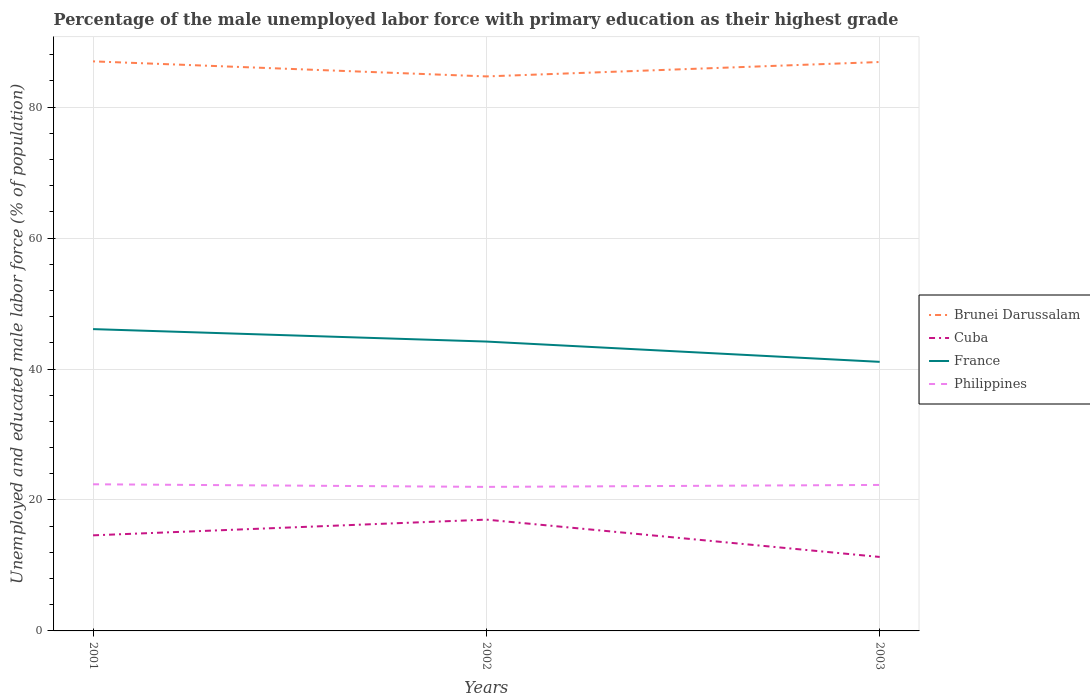How many different coloured lines are there?
Give a very brief answer. 4. Does the line corresponding to Philippines intersect with the line corresponding to Cuba?
Make the answer very short. No. Across all years, what is the maximum percentage of the unemployed male labor force with primary education in France?
Provide a succinct answer. 41.1. What is the total percentage of the unemployed male labor force with primary education in Brunei Darussalam in the graph?
Offer a very short reply. 2.3. What is the difference between the highest and the second highest percentage of the unemployed male labor force with primary education in Philippines?
Ensure brevity in your answer.  0.4. What is the difference between the highest and the lowest percentage of the unemployed male labor force with primary education in France?
Provide a succinct answer. 2. How many years are there in the graph?
Make the answer very short. 3. Are the values on the major ticks of Y-axis written in scientific E-notation?
Offer a very short reply. No. Does the graph contain any zero values?
Your answer should be compact. No. Where does the legend appear in the graph?
Provide a succinct answer. Center right. How are the legend labels stacked?
Make the answer very short. Vertical. What is the title of the graph?
Your answer should be compact. Percentage of the male unemployed labor force with primary education as their highest grade. What is the label or title of the Y-axis?
Provide a short and direct response. Unemployed and educated male labor force (% of population). What is the Unemployed and educated male labor force (% of population) of Cuba in 2001?
Provide a short and direct response. 14.6. What is the Unemployed and educated male labor force (% of population) of France in 2001?
Offer a terse response. 46.1. What is the Unemployed and educated male labor force (% of population) of Philippines in 2001?
Offer a terse response. 22.4. What is the Unemployed and educated male labor force (% of population) of Brunei Darussalam in 2002?
Provide a succinct answer. 84.7. What is the Unemployed and educated male labor force (% of population) of France in 2002?
Make the answer very short. 44.2. What is the Unemployed and educated male labor force (% of population) of Brunei Darussalam in 2003?
Provide a short and direct response. 86.9. What is the Unemployed and educated male labor force (% of population) of Cuba in 2003?
Your answer should be very brief. 11.3. What is the Unemployed and educated male labor force (% of population) in France in 2003?
Make the answer very short. 41.1. What is the Unemployed and educated male labor force (% of population) of Philippines in 2003?
Provide a succinct answer. 22.3. Across all years, what is the maximum Unemployed and educated male labor force (% of population) in Cuba?
Make the answer very short. 17. Across all years, what is the maximum Unemployed and educated male labor force (% of population) in France?
Offer a very short reply. 46.1. Across all years, what is the maximum Unemployed and educated male labor force (% of population) of Philippines?
Provide a short and direct response. 22.4. Across all years, what is the minimum Unemployed and educated male labor force (% of population) in Brunei Darussalam?
Your answer should be very brief. 84.7. Across all years, what is the minimum Unemployed and educated male labor force (% of population) of Cuba?
Offer a very short reply. 11.3. Across all years, what is the minimum Unemployed and educated male labor force (% of population) in France?
Offer a terse response. 41.1. What is the total Unemployed and educated male labor force (% of population) in Brunei Darussalam in the graph?
Your response must be concise. 258.6. What is the total Unemployed and educated male labor force (% of population) of Cuba in the graph?
Your answer should be compact. 42.9. What is the total Unemployed and educated male labor force (% of population) of France in the graph?
Your response must be concise. 131.4. What is the total Unemployed and educated male labor force (% of population) of Philippines in the graph?
Keep it short and to the point. 66.7. What is the difference between the Unemployed and educated male labor force (% of population) in Philippines in 2001 and that in 2002?
Ensure brevity in your answer.  0.4. What is the difference between the Unemployed and educated male labor force (% of population) of Philippines in 2002 and that in 2003?
Offer a very short reply. -0.3. What is the difference between the Unemployed and educated male labor force (% of population) of Brunei Darussalam in 2001 and the Unemployed and educated male labor force (% of population) of Cuba in 2002?
Keep it short and to the point. 70. What is the difference between the Unemployed and educated male labor force (% of population) in Brunei Darussalam in 2001 and the Unemployed and educated male labor force (% of population) in France in 2002?
Make the answer very short. 42.8. What is the difference between the Unemployed and educated male labor force (% of population) in Cuba in 2001 and the Unemployed and educated male labor force (% of population) in France in 2002?
Offer a terse response. -29.6. What is the difference between the Unemployed and educated male labor force (% of population) of France in 2001 and the Unemployed and educated male labor force (% of population) of Philippines in 2002?
Offer a very short reply. 24.1. What is the difference between the Unemployed and educated male labor force (% of population) of Brunei Darussalam in 2001 and the Unemployed and educated male labor force (% of population) of Cuba in 2003?
Keep it short and to the point. 75.7. What is the difference between the Unemployed and educated male labor force (% of population) of Brunei Darussalam in 2001 and the Unemployed and educated male labor force (% of population) of France in 2003?
Provide a short and direct response. 45.9. What is the difference between the Unemployed and educated male labor force (% of population) of Brunei Darussalam in 2001 and the Unemployed and educated male labor force (% of population) of Philippines in 2003?
Give a very brief answer. 64.7. What is the difference between the Unemployed and educated male labor force (% of population) in Cuba in 2001 and the Unemployed and educated male labor force (% of population) in France in 2003?
Your response must be concise. -26.5. What is the difference between the Unemployed and educated male labor force (% of population) in France in 2001 and the Unemployed and educated male labor force (% of population) in Philippines in 2003?
Your answer should be very brief. 23.8. What is the difference between the Unemployed and educated male labor force (% of population) of Brunei Darussalam in 2002 and the Unemployed and educated male labor force (% of population) of Cuba in 2003?
Ensure brevity in your answer.  73.4. What is the difference between the Unemployed and educated male labor force (% of population) of Brunei Darussalam in 2002 and the Unemployed and educated male labor force (% of population) of France in 2003?
Offer a very short reply. 43.6. What is the difference between the Unemployed and educated male labor force (% of population) in Brunei Darussalam in 2002 and the Unemployed and educated male labor force (% of population) in Philippines in 2003?
Make the answer very short. 62.4. What is the difference between the Unemployed and educated male labor force (% of population) of Cuba in 2002 and the Unemployed and educated male labor force (% of population) of France in 2003?
Offer a terse response. -24.1. What is the difference between the Unemployed and educated male labor force (% of population) in France in 2002 and the Unemployed and educated male labor force (% of population) in Philippines in 2003?
Offer a terse response. 21.9. What is the average Unemployed and educated male labor force (% of population) in Brunei Darussalam per year?
Make the answer very short. 86.2. What is the average Unemployed and educated male labor force (% of population) of Cuba per year?
Provide a short and direct response. 14.3. What is the average Unemployed and educated male labor force (% of population) of France per year?
Make the answer very short. 43.8. What is the average Unemployed and educated male labor force (% of population) in Philippines per year?
Ensure brevity in your answer.  22.23. In the year 2001, what is the difference between the Unemployed and educated male labor force (% of population) of Brunei Darussalam and Unemployed and educated male labor force (% of population) of Cuba?
Your response must be concise. 72.4. In the year 2001, what is the difference between the Unemployed and educated male labor force (% of population) of Brunei Darussalam and Unemployed and educated male labor force (% of population) of France?
Keep it short and to the point. 40.9. In the year 2001, what is the difference between the Unemployed and educated male labor force (% of population) of Brunei Darussalam and Unemployed and educated male labor force (% of population) of Philippines?
Your answer should be very brief. 64.6. In the year 2001, what is the difference between the Unemployed and educated male labor force (% of population) in Cuba and Unemployed and educated male labor force (% of population) in France?
Provide a short and direct response. -31.5. In the year 2001, what is the difference between the Unemployed and educated male labor force (% of population) of France and Unemployed and educated male labor force (% of population) of Philippines?
Give a very brief answer. 23.7. In the year 2002, what is the difference between the Unemployed and educated male labor force (% of population) in Brunei Darussalam and Unemployed and educated male labor force (% of population) in Cuba?
Offer a very short reply. 67.7. In the year 2002, what is the difference between the Unemployed and educated male labor force (% of population) in Brunei Darussalam and Unemployed and educated male labor force (% of population) in France?
Your answer should be very brief. 40.5. In the year 2002, what is the difference between the Unemployed and educated male labor force (% of population) in Brunei Darussalam and Unemployed and educated male labor force (% of population) in Philippines?
Ensure brevity in your answer.  62.7. In the year 2002, what is the difference between the Unemployed and educated male labor force (% of population) of Cuba and Unemployed and educated male labor force (% of population) of France?
Offer a terse response. -27.2. In the year 2003, what is the difference between the Unemployed and educated male labor force (% of population) in Brunei Darussalam and Unemployed and educated male labor force (% of population) in Cuba?
Offer a very short reply. 75.6. In the year 2003, what is the difference between the Unemployed and educated male labor force (% of population) in Brunei Darussalam and Unemployed and educated male labor force (% of population) in France?
Give a very brief answer. 45.8. In the year 2003, what is the difference between the Unemployed and educated male labor force (% of population) in Brunei Darussalam and Unemployed and educated male labor force (% of population) in Philippines?
Keep it short and to the point. 64.6. In the year 2003, what is the difference between the Unemployed and educated male labor force (% of population) of Cuba and Unemployed and educated male labor force (% of population) of France?
Provide a short and direct response. -29.8. In the year 2003, what is the difference between the Unemployed and educated male labor force (% of population) of Cuba and Unemployed and educated male labor force (% of population) of Philippines?
Offer a very short reply. -11. What is the ratio of the Unemployed and educated male labor force (% of population) of Brunei Darussalam in 2001 to that in 2002?
Your answer should be very brief. 1.03. What is the ratio of the Unemployed and educated male labor force (% of population) of Cuba in 2001 to that in 2002?
Provide a short and direct response. 0.86. What is the ratio of the Unemployed and educated male labor force (% of population) of France in 2001 to that in 2002?
Keep it short and to the point. 1.04. What is the ratio of the Unemployed and educated male labor force (% of population) of Philippines in 2001 to that in 2002?
Offer a very short reply. 1.02. What is the ratio of the Unemployed and educated male labor force (% of population) in Cuba in 2001 to that in 2003?
Give a very brief answer. 1.29. What is the ratio of the Unemployed and educated male labor force (% of population) of France in 2001 to that in 2003?
Offer a very short reply. 1.12. What is the ratio of the Unemployed and educated male labor force (% of population) of Philippines in 2001 to that in 2003?
Offer a terse response. 1. What is the ratio of the Unemployed and educated male labor force (% of population) in Brunei Darussalam in 2002 to that in 2003?
Your answer should be very brief. 0.97. What is the ratio of the Unemployed and educated male labor force (% of population) in Cuba in 2002 to that in 2003?
Make the answer very short. 1.5. What is the ratio of the Unemployed and educated male labor force (% of population) of France in 2002 to that in 2003?
Provide a succinct answer. 1.08. What is the ratio of the Unemployed and educated male labor force (% of population) of Philippines in 2002 to that in 2003?
Keep it short and to the point. 0.99. What is the difference between the highest and the second highest Unemployed and educated male labor force (% of population) in France?
Ensure brevity in your answer.  1.9. What is the difference between the highest and the lowest Unemployed and educated male labor force (% of population) of Brunei Darussalam?
Provide a short and direct response. 2.3. What is the difference between the highest and the lowest Unemployed and educated male labor force (% of population) of Cuba?
Offer a terse response. 5.7. What is the difference between the highest and the lowest Unemployed and educated male labor force (% of population) of France?
Your answer should be very brief. 5. What is the difference between the highest and the lowest Unemployed and educated male labor force (% of population) of Philippines?
Provide a succinct answer. 0.4. 